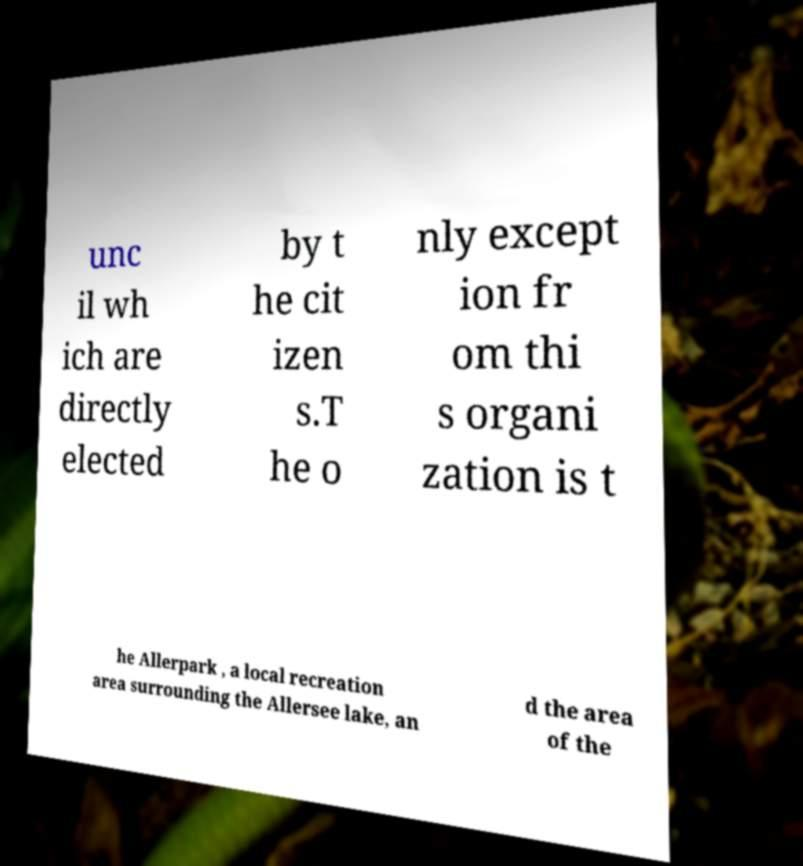Can you accurately transcribe the text from the provided image for me? unc il wh ich are directly elected by t he cit izen s.T he o nly except ion fr om thi s organi zation is t he Allerpark , a local recreation area surrounding the Allersee lake, an d the area of the 